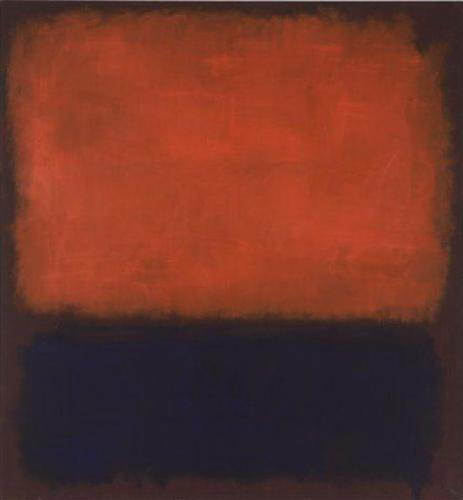Imagine you could step into the artwork. What do you see and feel? Stepping into the artwork, you find yourself enveloped in an expansive field of textured red above and an abyssal, smooth black below. The red surrounds you with intensity and fervor, its rough texture resonating with a visceral energy that seems almost palpable. The cool, smooth black beneath your feet offers a stark contrast, grounding you with a sense of calm and solemnity in this surreal environment. The intersection of these contrasting elements might provoke a sense of introspection, challenging you to balance the passion and the mystery that envelops you.  Can you create a short poem inspired by this painting? Crimson sky of fervent dreams,
A black abyss where silence screams.
Textures weave a tale of old,
In contrasts bold, our stories told. 